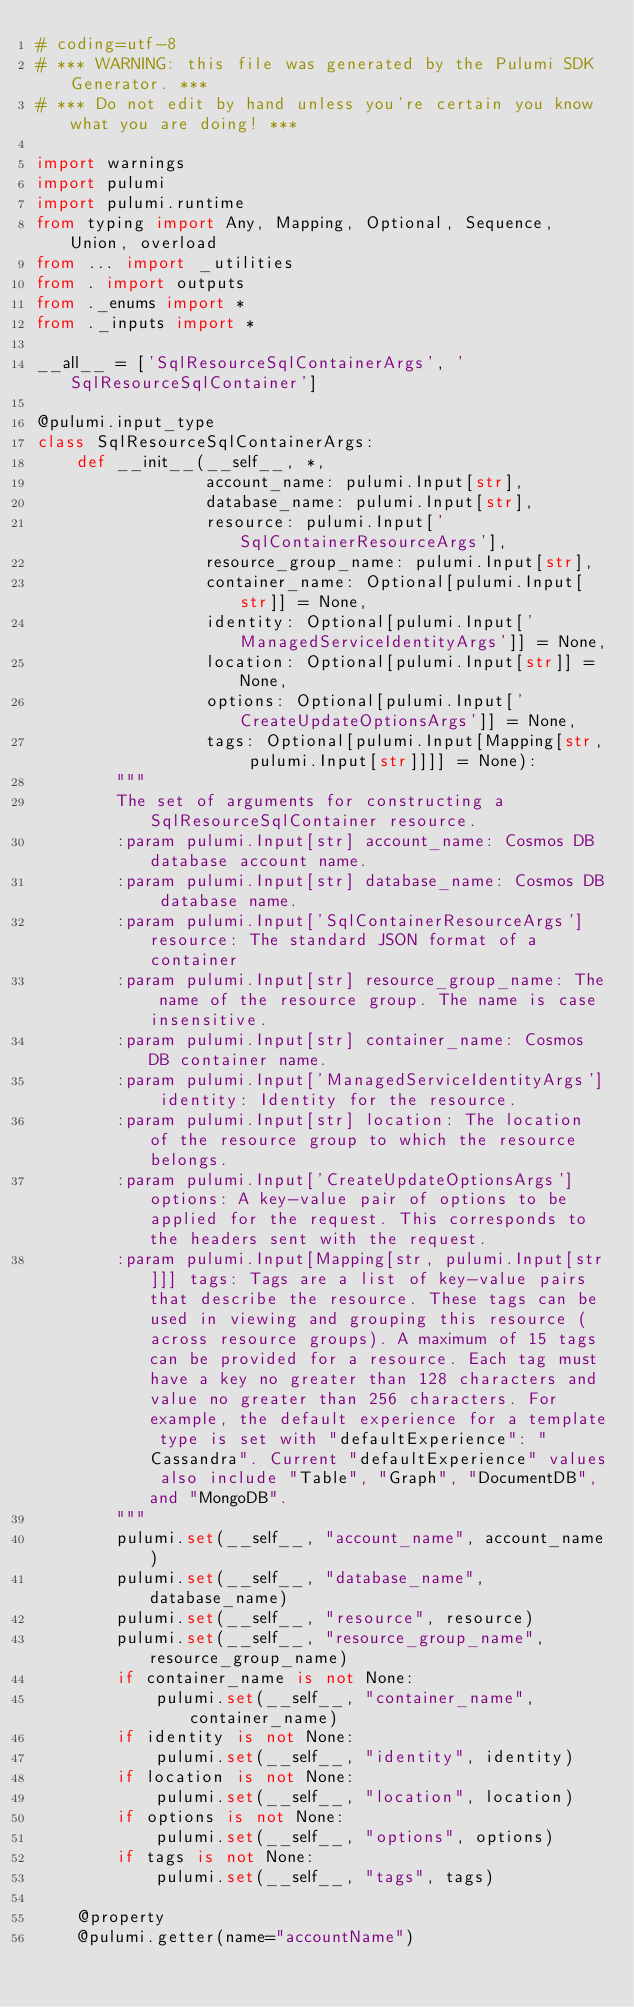Convert code to text. <code><loc_0><loc_0><loc_500><loc_500><_Python_># coding=utf-8
# *** WARNING: this file was generated by the Pulumi SDK Generator. ***
# *** Do not edit by hand unless you're certain you know what you are doing! ***

import warnings
import pulumi
import pulumi.runtime
from typing import Any, Mapping, Optional, Sequence, Union, overload
from ... import _utilities
from . import outputs
from ._enums import *
from ._inputs import *

__all__ = ['SqlResourceSqlContainerArgs', 'SqlResourceSqlContainer']

@pulumi.input_type
class SqlResourceSqlContainerArgs:
    def __init__(__self__, *,
                 account_name: pulumi.Input[str],
                 database_name: pulumi.Input[str],
                 resource: pulumi.Input['SqlContainerResourceArgs'],
                 resource_group_name: pulumi.Input[str],
                 container_name: Optional[pulumi.Input[str]] = None,
                 identity: Optional[pulumi.Input['ManagedServiceIdentityArgs']] = None,
                 location: Optional[pulumi.Input[str]] = None,
                 options: Optional[pulumi.Input['CreateUpdateOptionsArgs']] = None,
                 tags: Optional[pulumi.Input[Mapping[str, pulumi.Input[str]]]] = None):
        """
        The set of arguments for constructing a SqlResourceSqlContainer resource.
        :param pulumi.Input[str] account_name: Cosmos DB database account name.
        :param pulumi.Input[str] database_name: Cosmos DB database name.
        :param pulumi.Input['SqlContainerResourceArgs'] resource: The standard JSON format of a container
        :param pulumi.Input[str] resource_group_name: The name of the resource group. The name is case insensitive.
        :param pulumi.Input[str] container_name: Cosmos DB container name.
        :param pulumi.Input['ManagedServiceIdentityArgs'] identity: Identity for the resource.
        :param pulumi.Input[str] location: The location of the resource group to which the resource belongs.
        :param pulumi.Input['CreateUpdateOptionsArgs'] options: A key-value pair of options to be applied for the request. This corresponds to the headers sent with the request.
        :param pulumi.Input[Mapping[str, pulumi.Input[str]]] tags: Tags are a list of key-value pairs that describe the resource. These tags can be used in viewing and grouping this resource (across resource groups). A maximum of 15 tags can be provided for a resource. Each tag must have a key no greater than 128 characters and value no greater than 256 characters. For example, the default experience for a template type is set with "defaultExperience": "Cassandra". Current "defaultExperience" values also include "Table", "Graph", "DocumentDB", and "MongoDB".
        """
        pulumi.set(__self__, "account_name", account_name)
        pulumi.set(__self__, "database_name", database_name)
        pulumi.set(__self__, "resource", resource)
        pulumi.set(__self__, "resource_group_name", resource_group_name)
        if container_name is not None:
            pulumi.set(__self__, "container_name", container_name)
        if identity is not None:
            pulumi.set(__self__, "identity", identity)
        if location is not None:
            pulumi.set(__self__, "location", location)
        if options is not None:
            pulumi.set(__self__, "options", options)
        if tags is not None:
            pulumi.set(__self__, "tags", tags)

    @property
    @pulumi.getter(name="accountName")</code> 